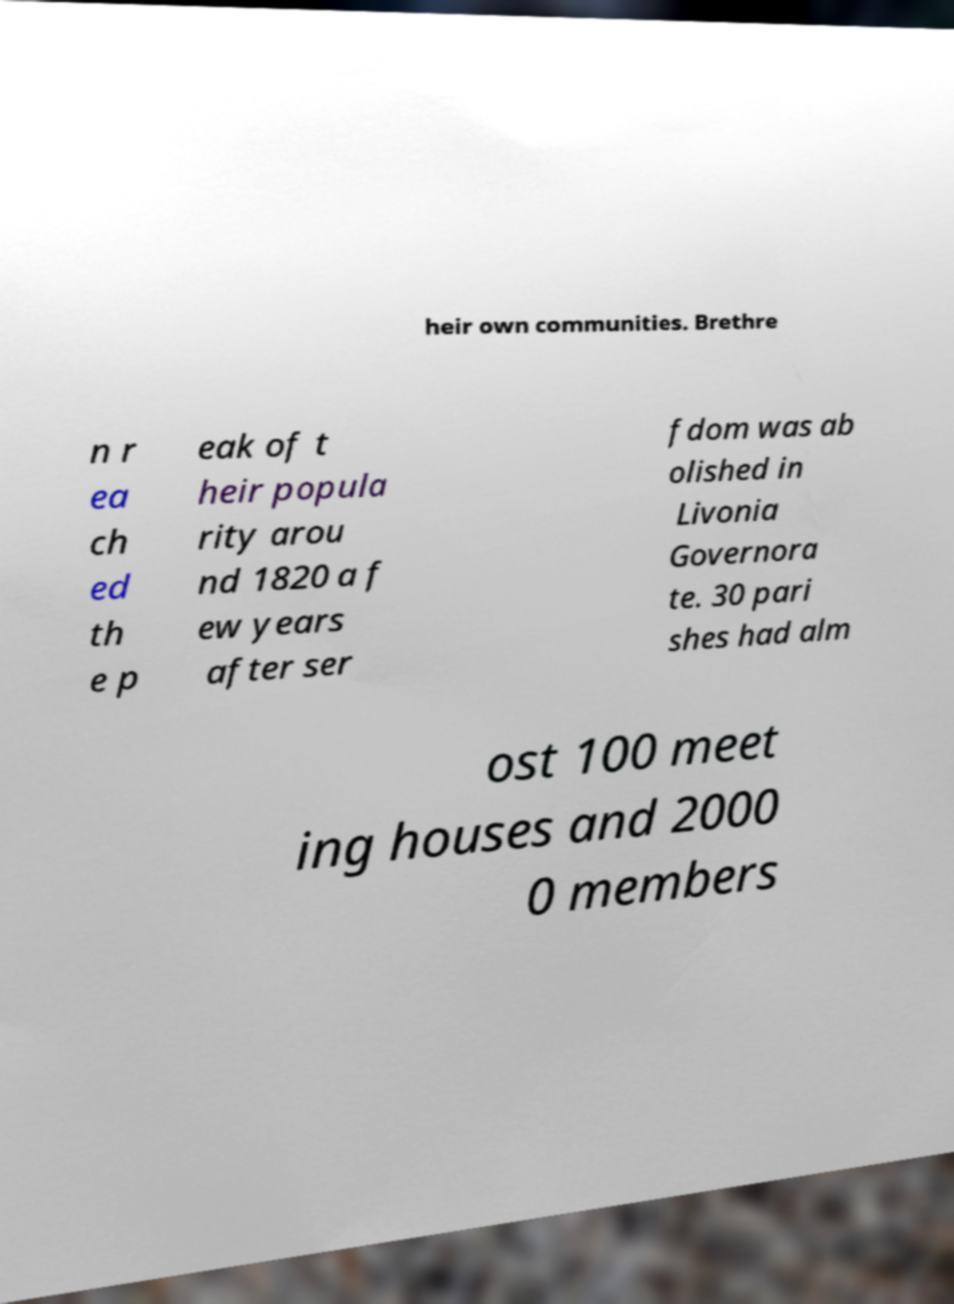Can you read and provide the text displayed in the image?This photo seems to have some interesting text. Can you extract and type it out for me? heir own communities. Brethre n r ea ch ed th e p eak of t heir popula rity arou nd 1820 a f ew years after ser fdom was ab olished in Livonia Governora te. 30 pari shes had alm ost 100 meet ing houses and 2000 0 members 